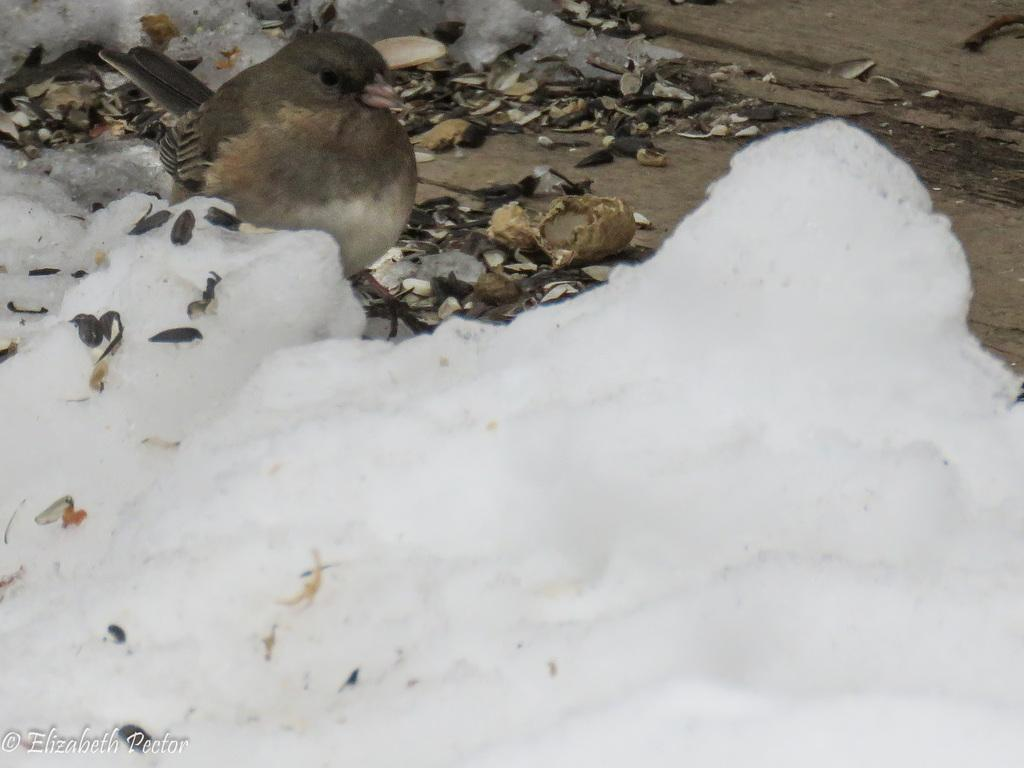What is the primary feature of the landscape in the image? There is snow in the image. What can be seen beneath the snow? The ground is visible in the image. Are there any objects on the ground? Yes, there are objects on the ground. What type of animal is present in the image? There is a bird in the image. Can you describe the bird's appearance? The bird has grey, black, and cream coloring. What type of cork can be seen in the bird's nest in the image? There is no bird's nest or cork present in the image. How does the bird's presence provide comfort to the grandmother in the image? There is no grandmother present in the image, and the bird's presence does not provide comfort to anyone. 